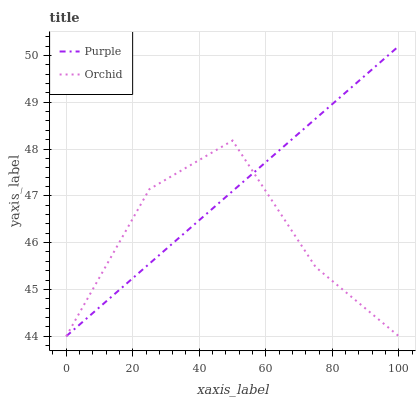Does Orchid have the minimum area under the curve?
Answer yes or no. Yes. Does Purple have the maximum area under the curve?
Answer yes or no. Yes. Does Orchid have the maximum area under the curve?
Answer yes or no. No. Is Purple the smoothest?
Answer yes or no. Yes. Is Orchid the roughest?
Answer yes or no. Yes. Is Orchid the smoothest?
Answer yes or no. No. Does Purple have the lowest value?
Answer yes or no. Yes. Does Purple have the highest value?
Answer yes or no. Yes. Does Orchid have the highest value?
Answer yes or no. No. Does Orchid intersect Purple?
Answer yes or no. Yes. Is Orchid less than Purple?
Answer yes or no. No. Is Orchid greater than Purple?
Answer yes or no. No. 